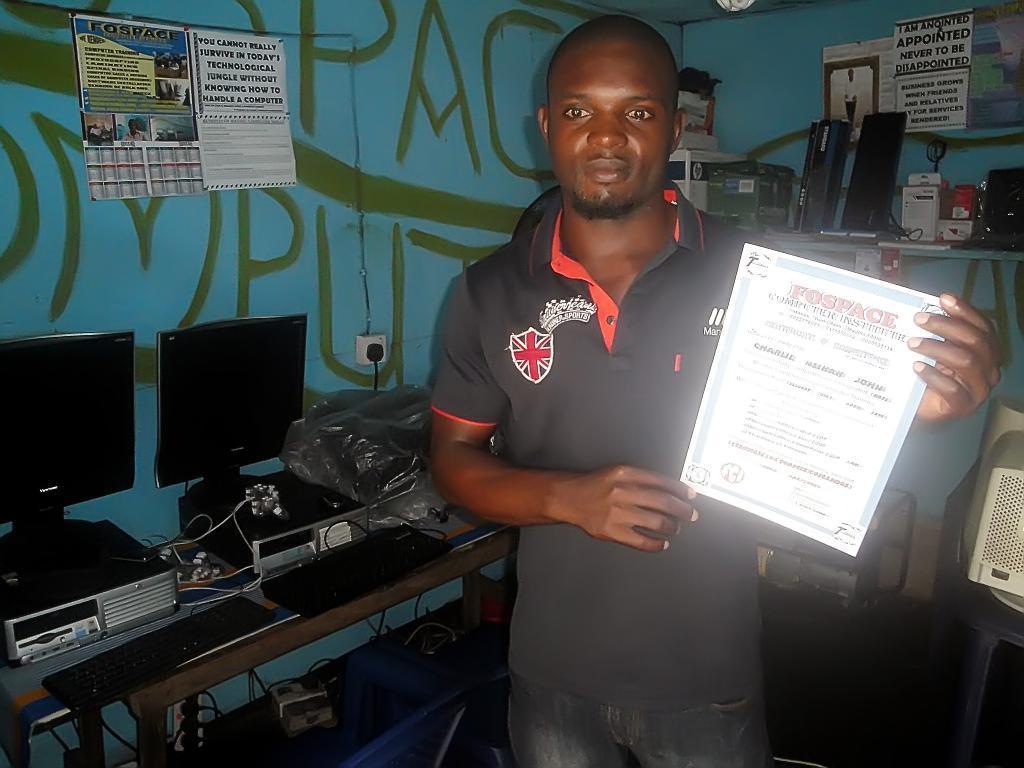Please provide a concise description of this image. In this image we can see a man standing and holding a memorandum. There is a table and we can see computers, keyboards and a cover placed on the table. In the background there is a shelf and we can see things placed in the shelf. There are papers pasted on the wall. 